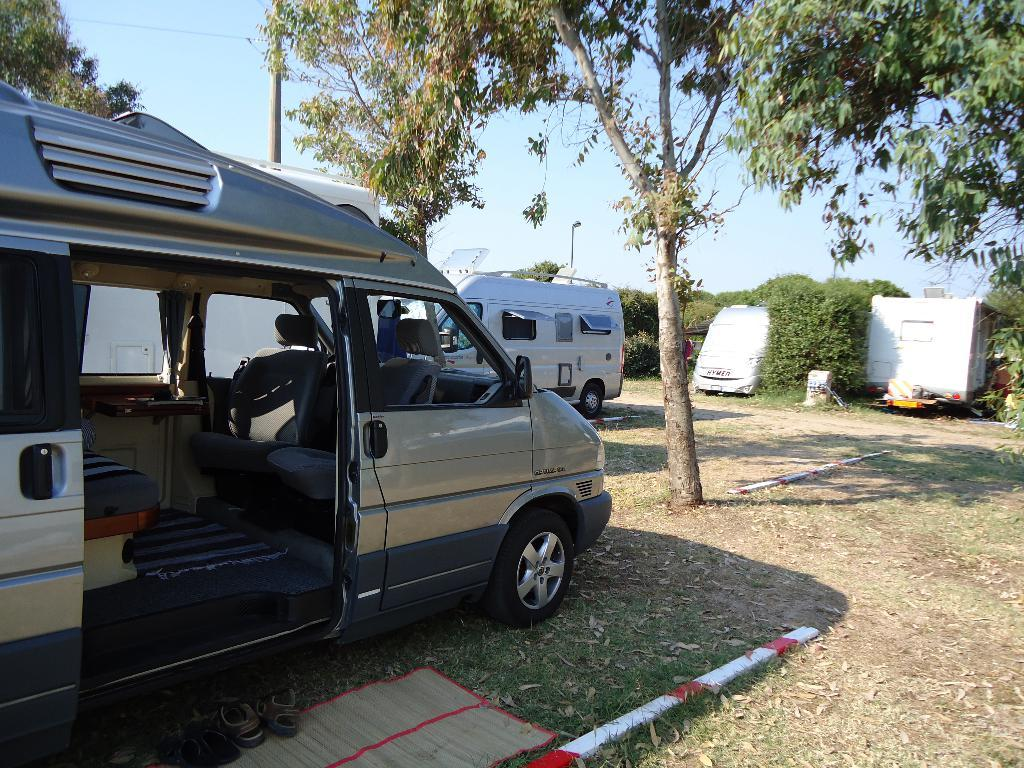What types of objects can be seen in the image? There are vehicles, a mat, footwear, grass, trees, poles, a light, and unspecified objects in the image. Can you describe the setting of the image? The image features grass, trees, and the sky visible in the background, suggesting an outdoor setting. What might be used for standing or parking in the image? The poles and vehicles in the image might be used for standing or parking. What can be seen on the ground in the image? The mat and grass are visible on the ground in the image. What type of soup is being served in the image? There is no soup present in the image. How does the wind affect the objects in the image? The image does not depict any wind or its effects on the objects. 